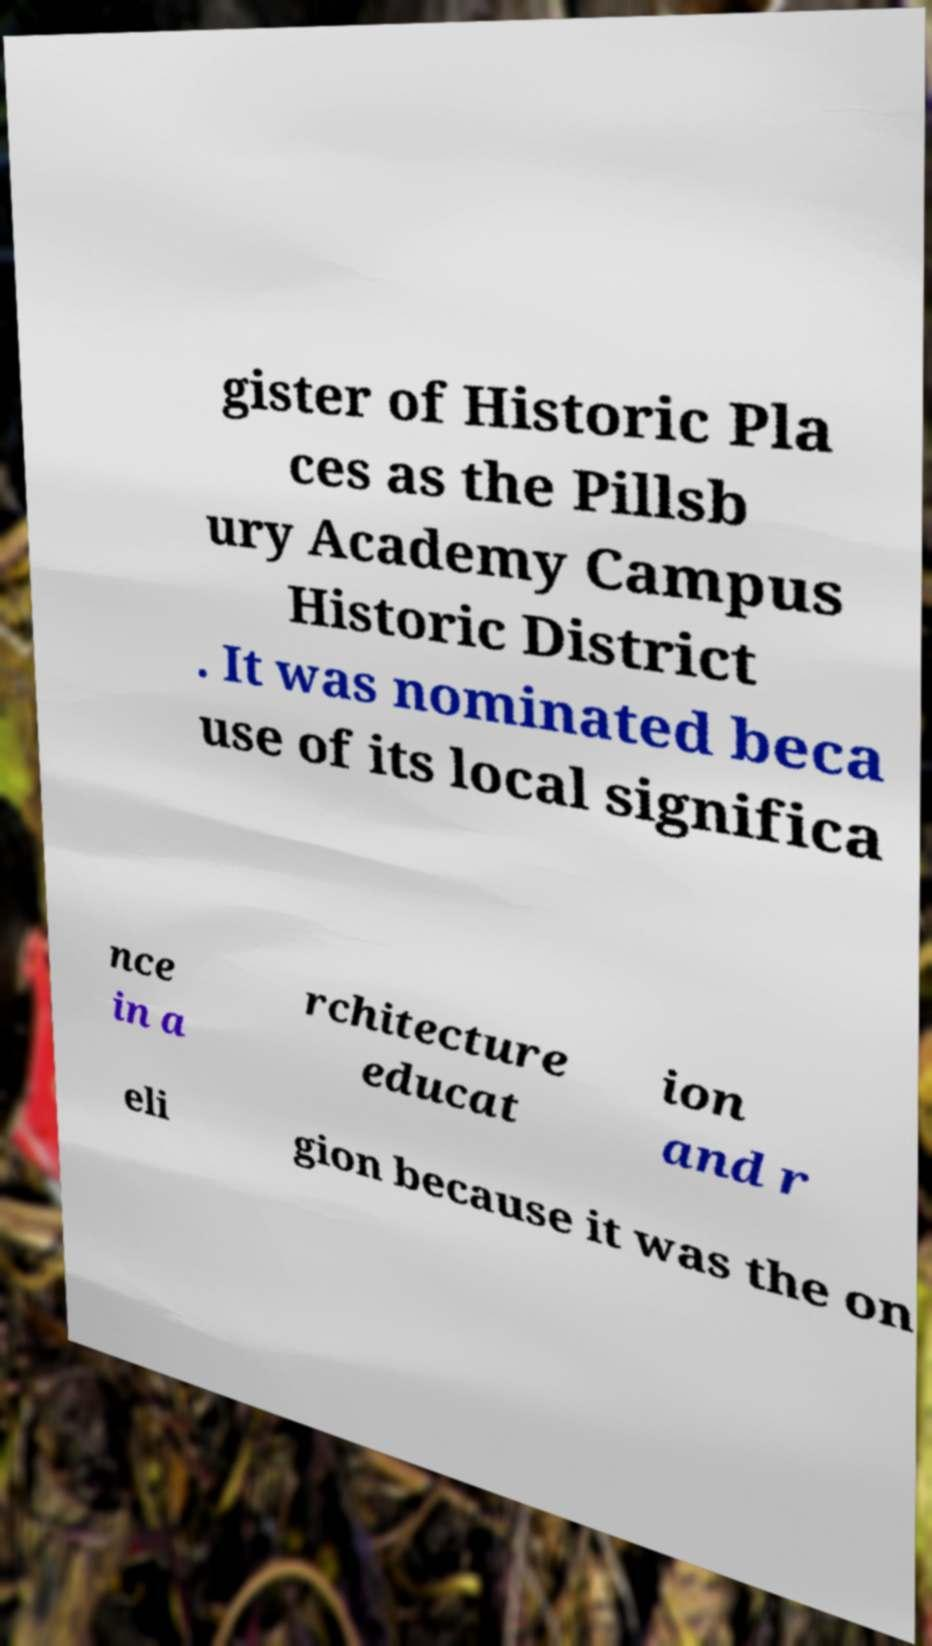Could you assist in decoding the text presented in this image and type it out clearly? gister of Historic Pla ces as the Pillsb ury Academy Campus Historic District . It was nominated beca use of its local significa nce in a rchitecture educat ion and r eli gion because it was the on 